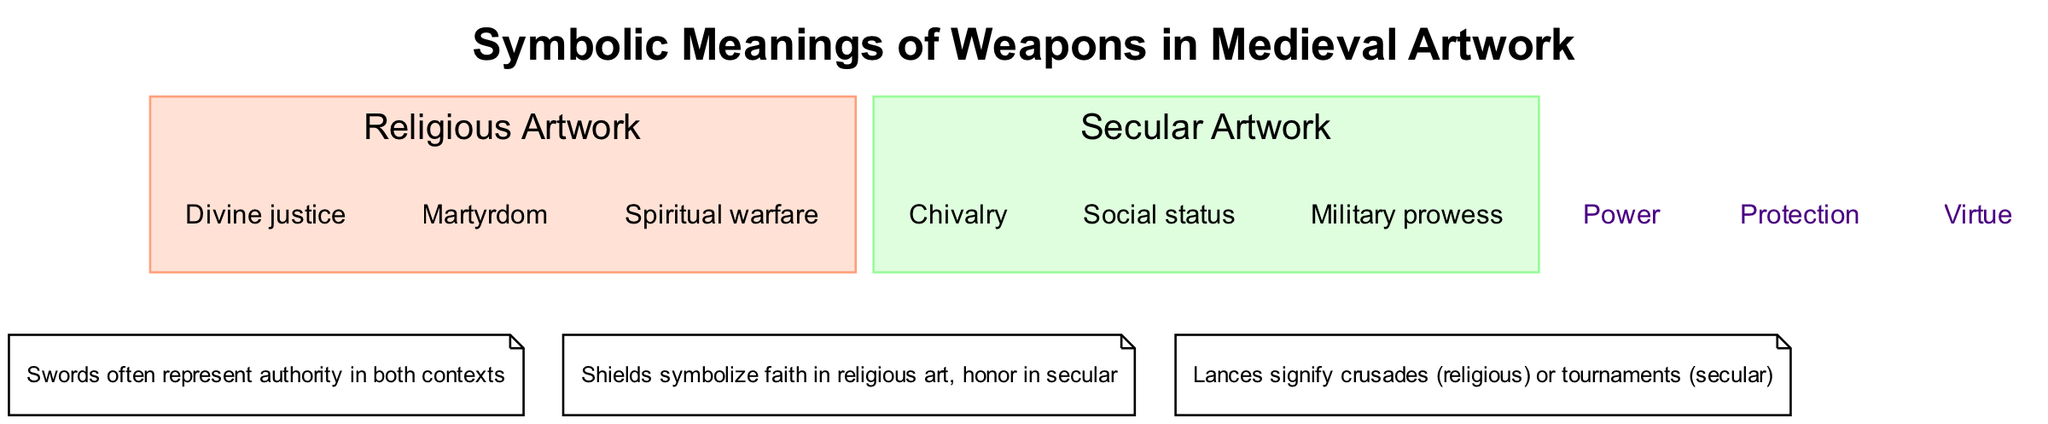What are the elements in Religious Artwork? The diagram indicates that the elements listed under the Religious Artwork circle are "Divine justice," "Martyrdom," and "Spiritual warfare." Therefore, the answer contains these specific elements that symbolize the meanings of weapons in religious contexts.
Answer: Divine justice, Martyrdom, Spiritual warfare How many elements are there in Secular Artwork? The Secular Artwork circle contains three elements: "Chivalry," "Social status," and "Military prowess." By counting these elements, we can conclude that the total is three.
Answer: 3 What is found in the intersection of both circles? The intersection of the circles highlights shared meanings attributed to weapons in both religious and secular artwork. It lists "Power," "Protection," and "Virtue" as common symbolic meanings.
Answer: Power, Protection, Virtue What does the Shield symbolize in religious art? According to the notes in the diagram, the Shield symbolizes faith within the context of religious artwork, indicating its role in religious narratives and representations.
Answer: Faith Which weapon is associated with Chivalry? The diagram indicates that the concept of Chivalry is primarily represented through the sword in secular artwork. This association highlights the sword's role in depicting honor and knightly virtues.
Answer: Sword What common meaning is attributed to weapons in both religious and secular contexts? The shared meaning in the intersection highlights that weapons symbolize "Power," which represents a fundamental aspect attributed to the use of weapons across both types of artwork.
Answer: Power Which element signifies crusades? The diagram explicitly states that lances signify crusades in religious contexts, indicating their association with religious warfare during the medieval period.
Answer: Lances How many notes are included in the diagram? The diagram includes a total of three notes detailing specific symbolic meanings attributed to weapons in both types of artworks. These notes add additional context to the understanding of the diagram.
Answer: 3 